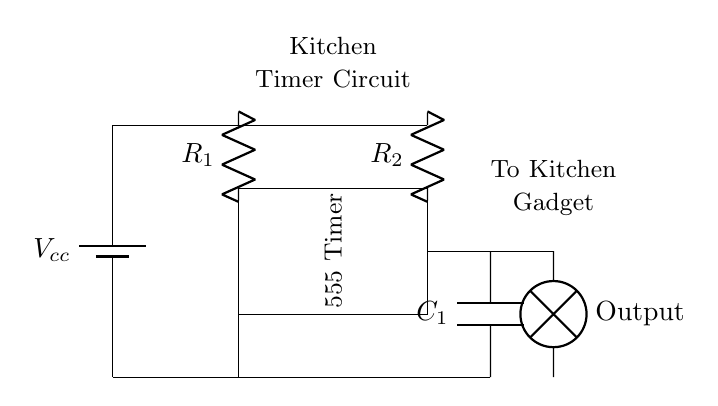What is the power supply voltage? The circuit shows a battery labeled with Vcc, which typically indicates the power supply voltage. The exact value isn't provided but it's common to see 5V or 9V.
Answer: Vcc What component is used to control timing? The 555 Timer IC is present in the circuit, which is the primary component responsible for timing functions.
Answer: 555 Timer What type of component is C1? The symbol for C1 indicates a capacitor, which is crucial for timing applications in the circuit.
Answer: Capacitor How many resistors are in this circuit? There are two resistors (R1 and R2) shown in the circuit, which affect the timing interval.
Answer: 2 Which component outputs to the kitchen gadget? The output from the circuit flows through a lamp symbol leading to "To Kitchen Gadget," indicating this is the output of the timer function.
Answer: Lamp What is the function of R1? R1 is a resistor that, along with R2 and C1, determines the timing interval of the 555 Timer circuit.
Answer: Timing control What does the lamp represent? The lamp in the circuit symbolizes the output indication, showing that the timer has triggered the connected kitchen gadget.
Answer: Output 